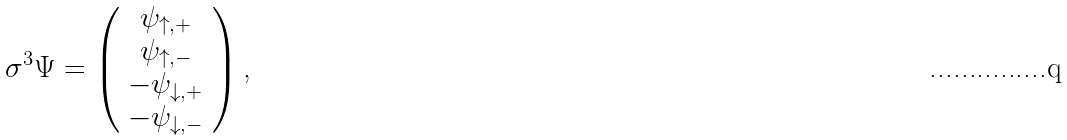<formula> <loc_0><loc_0><loc_500><loc_500>\sigma ^ { 3 } \Psi = \left ( \begin{array} { c } \psi _ { \uparrow , + } \\ \psi _ { \uparrow , - } \\ - \psi _ { \downarrow , + } \\ - \psi _ { \downarrow , - } \end{array} \right ) \text {,}</formula> 